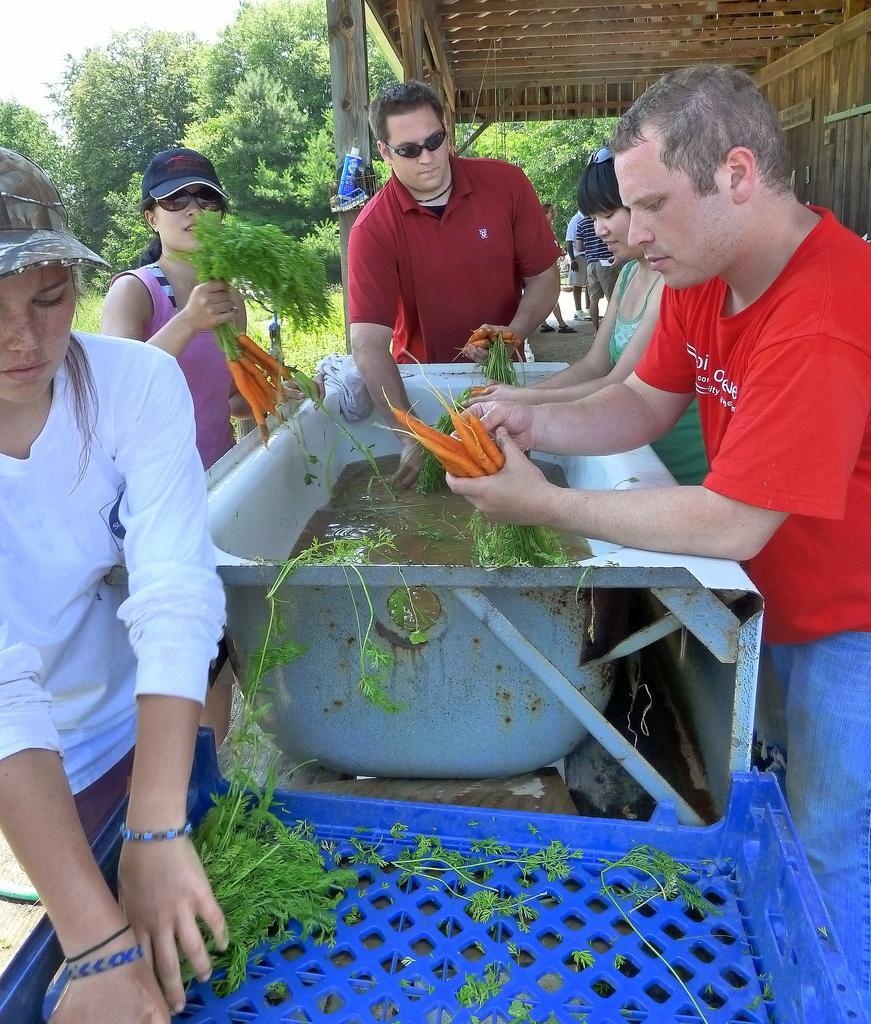Could you give a brief overview of what you see in this image? In this image I can observe few people. Some of them are holding carrots. In the background there is a tree. 